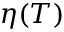<formula> <loc_0><loc_0><loc_500><loc_500>\eta ( T )</formula> 